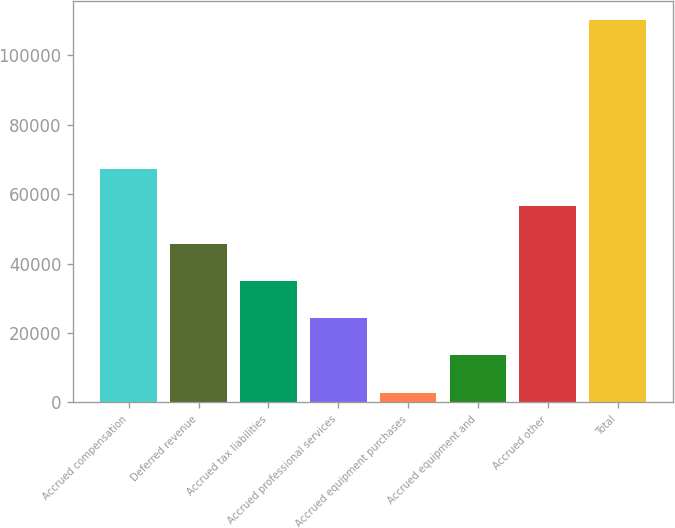<chart> <loc_0><loc_0><loc_500><loc_500><bar_chart><fcel>Accrued compensation<fcel>Deferred revenue<fcel>Accrued tax liabilities<fcel>Accrued professional services<fcel>Accrued equipment purchases<fcel>Accrued equipment and<fcel>Accrued other<fcel>Total<nl><fcel>67308.8<fcel>45808.2<fcel>35057.9<fcel>24307.6<fcel>2807<fcel>13557.3<fcel>56558.5<fcel>110310<nl></chart> 